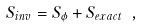<formula> <loc_0><loc_0><loc_500><loc_500>S _ { i n v } = S _ { \phi } + S _ { e x a c t } \ ,</formula> 